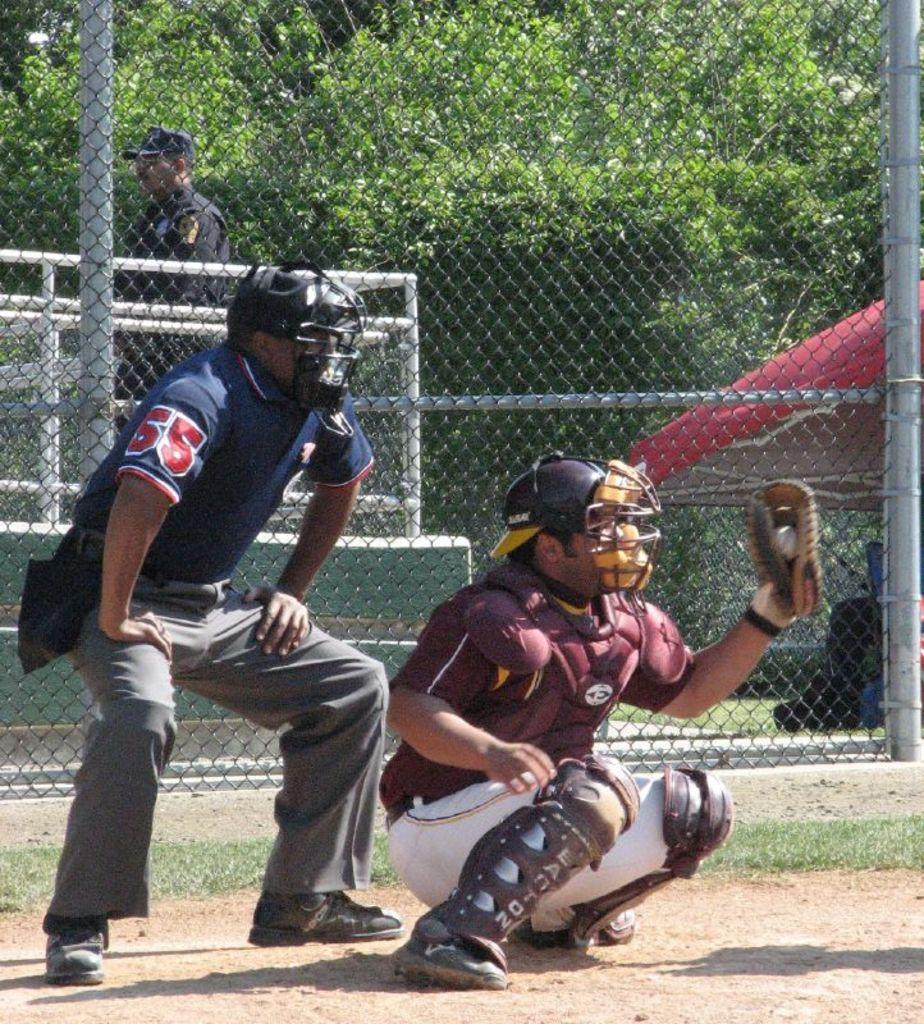How many people are present in the image? There are three people in the image. What object can be seen in the image that provides protection from the rain? There is an umbrella in the image. What type of barrier can be seen in the image? There is a fence in the image. What type of vegetation is visible in the image? There are trees in the image. What type of yam is being used as a hat in the image? There is no yam present in the image, let alone being used as a hat. 